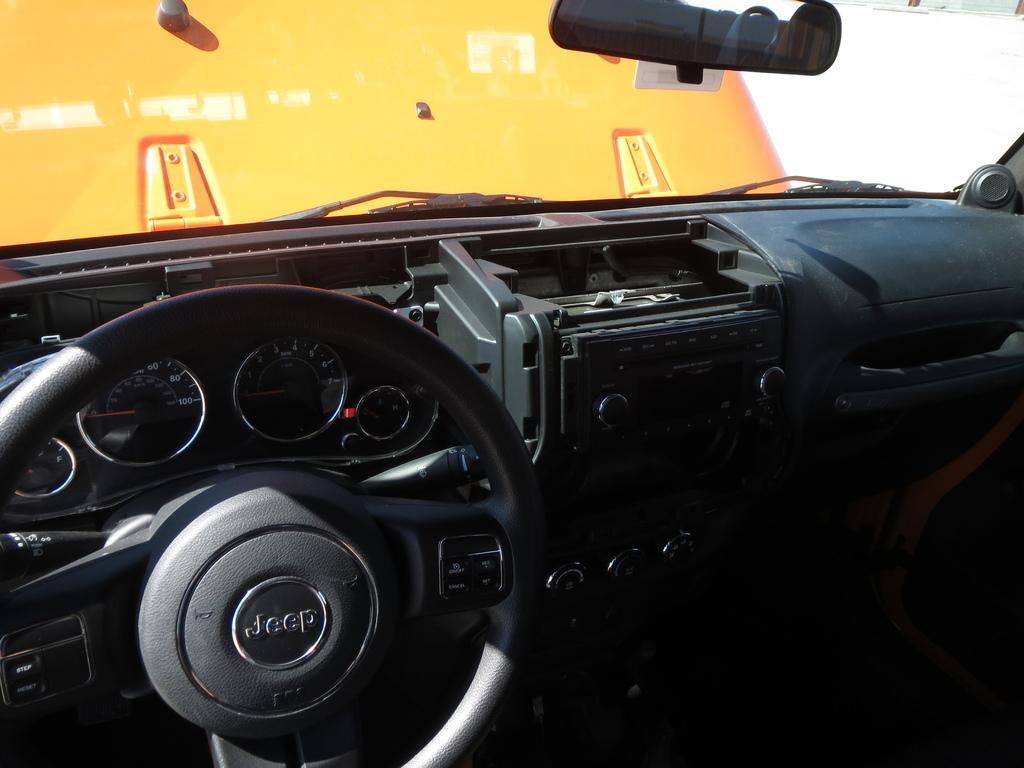In one or two sentences, can you explain what this image depicts? In this image we can see the inner view of a motor vehicle. 